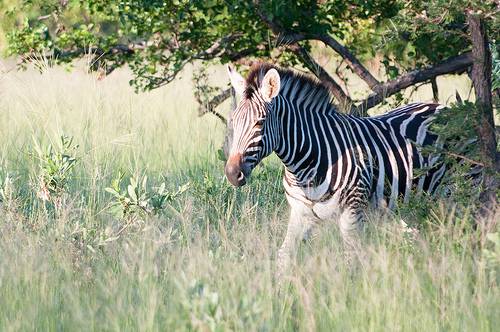Please provide a short description for this region: [0.52, 0.51, 0.72, 0.71]. In the region defined by the coordinates [0.52, 0.51, 0.72, 0.71], we observe a portion of a zebra's white chest. The distinct pattern of the zebra's stripes is clearly visible. 